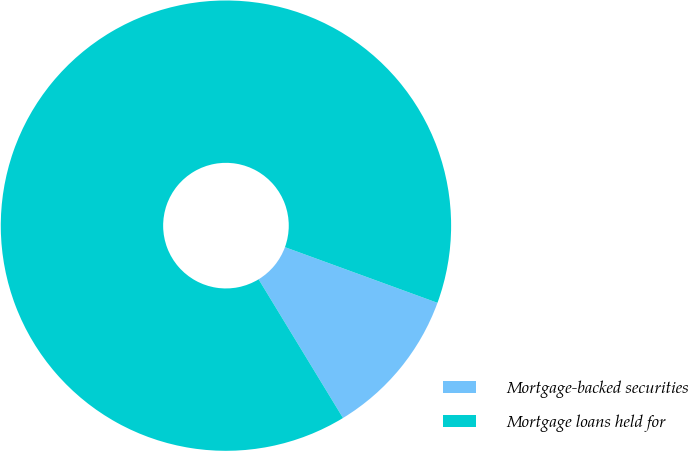Convert chart. <chart><loc_0><loc_0><loc_500><loc_500><pie_chart><fcel>Mortgage-backed securities<fcel>Mortgage loans held for<nl><fcel>10.73%<fcel>89.27%<nl></chart> 